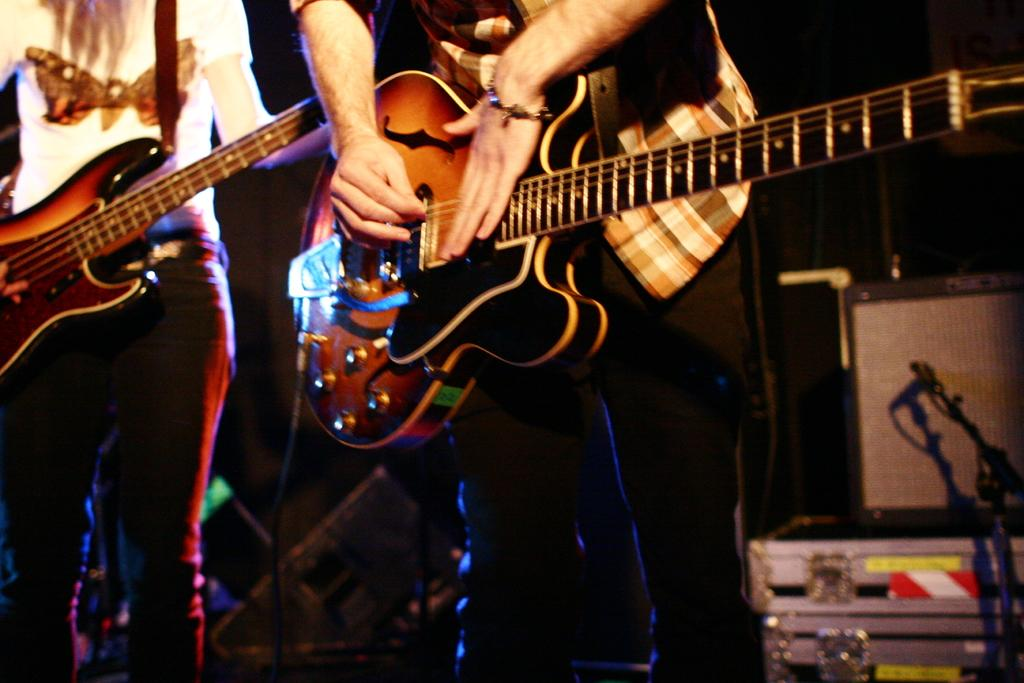How many people are in the image? There are two people in the image. What are the two people doing in the image? The two people are standing and holding a guitar. What type of rose can be seen growing near the two people in the image? There is no rose present in the image; it only features two people holding a guitar. 